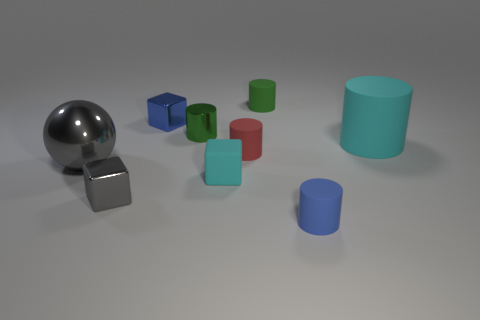What shape is the gray thing left of the small gray object?
Provide a succinct answer. Sphere. How many blue things are both on the left side of the tiny rubber cube and in front of the gray cube?
Offer a very short reply. 0. There is a gray sphere; is it the same size as the cyan matte thing in front of the big matte object?
Keep it short and to the point. No. What size is the shiny cube in front of the big object that is behind the red thing behind the blue rubber cylinder?
Your response must be concise. Small. There is a cyan thing behind the big gray metal thing; what is its size?
Keep it short and to the point. Large. The tiny blue object that is made of the same material as the large ball is what shape?
Provide a succinct answer. Cube. Are the blue thing that is to the right of the small green matte thing and the small gray thing made of the same material?
Offer a terse response. No. How many other things are there of the same material as the small blue cube?
Your answer should be very brief. 3. How many things are small shiny cubes that are in front of the metal sphere or objects that are right of the small blue cylinder?
Give a very brief answer. 2. There is a tiny blue thing that is in front of the ball; does it have the same shape as the cyan matte thing that is behind the ball?
Your answer should be compact. Yes. 